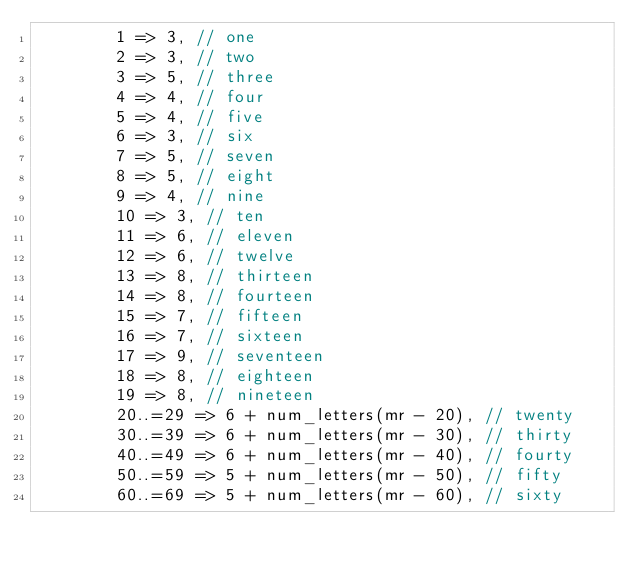Convert code to text. <code><loc_0><loc_0><loc_500><loc_500><_Rust_>        1 => 3, // one
        2 => 3, // two
        3 => 5, // three
        4 => 4, // four
        5 => 4, // five
        6 => 3, // six
        7 => 5, // seven
        8 => 5, // eight
        9 => 4, // nine
        10 => 3, // ten
        11 => 6, // eleven
        12 => 6, // twelve
        13 => 8, // thirteen
        14 => 8, // fourteen
        15 => 7, // fifteen
        16 => 7, // sixteen
        17 => 9, // seventeen
        18 => 8, // eighteen
        19 => 8, // nineteen
        20..=29 => 6 + num_letters(mr - 20), // twenty
        30..=39 => 6 + num_letters(mr - 30), // thirty
        40..=49 => 6 + num_letters(mr - 40), // fourty
        50..=59 => 5 + num_letters(mr - 50), // fifty
        60..=69 => 5 + num_letters(mr - 60), // sixty</code> 